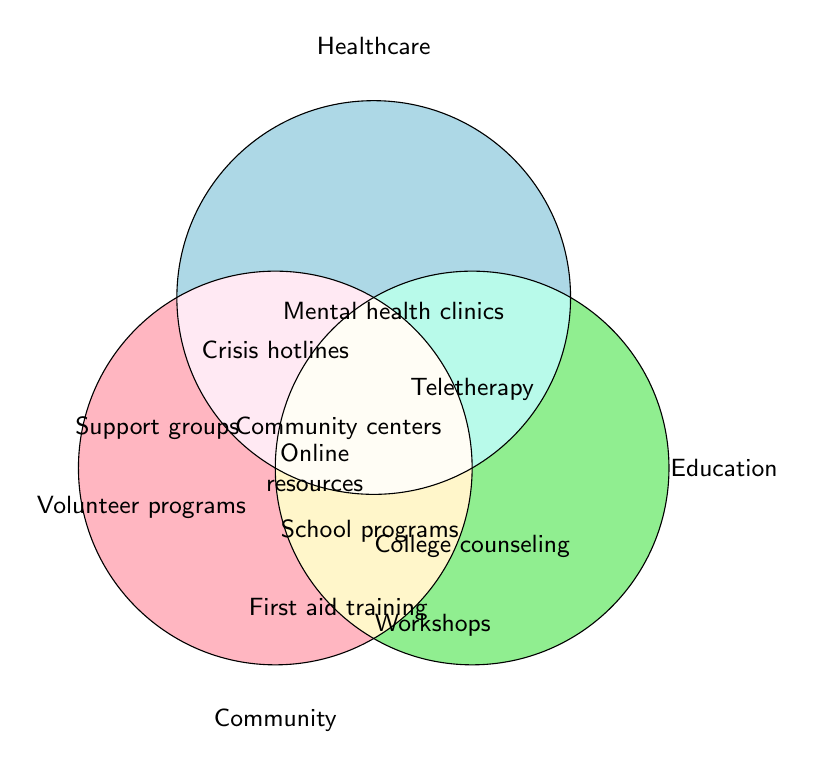What are the categories displayed in the Venn Diagram? The Venn Diagram shows three categories, each represented by a circle. The labels indicate the categories as "Community", "Healthcare", and "Education".
Answer: Community, Healthcare, Education Which category is represented by the pink colored circle? The pink colored circle is labeled with the word "Community" at the bottom.
Answer: Community What resource overlaps between Community and Healthcare? The resource that overlaps between Community and Healthcare is written in the intersection of the two circles. It is labeled as "Crisis hotlines" and "Community mental health centers".
Answer: Crisis hotlines, Community mental health centers How many specific resources are listed under the Healthcare category alone? By looking at the individual section of the Healthcare circle (blue color) that doesn't intersect with others, we can count the specific resources mentioned: "Mental health clinics," "Hospital psychiatric units," and "Teletherapy services."
Answer: 3 What resource is common to all three categories: Community, Healthcare, and Education? The center where all three circles overlap contains the resource that is common to all categories. This area is labeled with "Online mental health resources".
Answer: Online mental health resources Where is "Volunteer programs" listed in the diagram? "Volunteer programs" can be found within the individual section of the Community circle, in the pink-colored area without overlap from other circles.
Answer: Community Which category has resources for "Mental health awareness workshops"? "Mental health awareness workshops" is located within the individual section of the Education circle, indicated by the green color.
Answer: Education What are the resources listed under Community that do not overlap with Healthcare or Education? By checking the pink circle sections that do not overlap, we find the resources listed are "Local support groups," "Volunteer programs," and "Family counseling centers."
Answer: Local support groups, Volunteer programs, Family counseling centers Identify a resource that overlaps between Healthcare and Education but not with Community. The intersection between the Healthcare (blue) and Education (green) circles excluding the pink (Community) area contains "Mental health first aid training."
Answer: Mental health first aid training Count the total number of distinct resources listed in the Venn Diagram. By counting each unique resource from the individual circles and their intersections, we find there are 13 distinct resources labeled in the diagram.
Answer: 13 